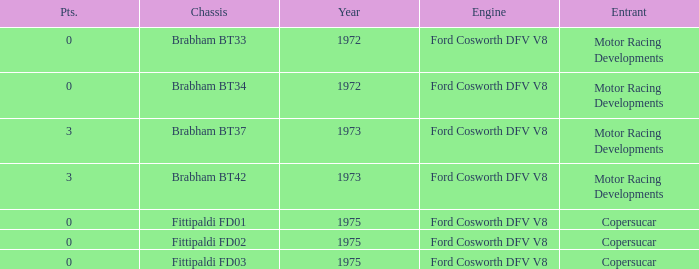Which chassis is more recent than 1972 and has more than 0 Pts. ? Brabham BT37, Brabham BT42. Help me parse the entirety of this table. {'header': ['Pts.', 'Chassis', 'Year', 'Engine', 'Entrant'], 'rows': [['0', 'Brabham BT33', '1972', 'Ford Cosworth DFV V8', 'Motor Racing Developments'], ['0', 'Brabham BT34', '1972', 'Ford Cosworth DFV V8', 'Motor Racing Developments'], ['3', 'Brabham BT37', '1973', 'Ford Cosworth DFV V8', 'Motor Racing Developments'], ['3', 'Brabham BT42', '1973', 'Ford Cosworth DFV V8', 'Motor Racing Developments'], ['0', 'Fittipaldi FD01', '1975', 'Ford Cosworth DFV V8', 'Copersucar'], ['0', 'Fittipaldi FD02', '1975', 'Ford Cosworth DFV V8', 'Copersucar'], ['0', 'Fittipaldi FD03', '1975', 'Ford Cosworth DFV V8', 'Copersucar']]} 